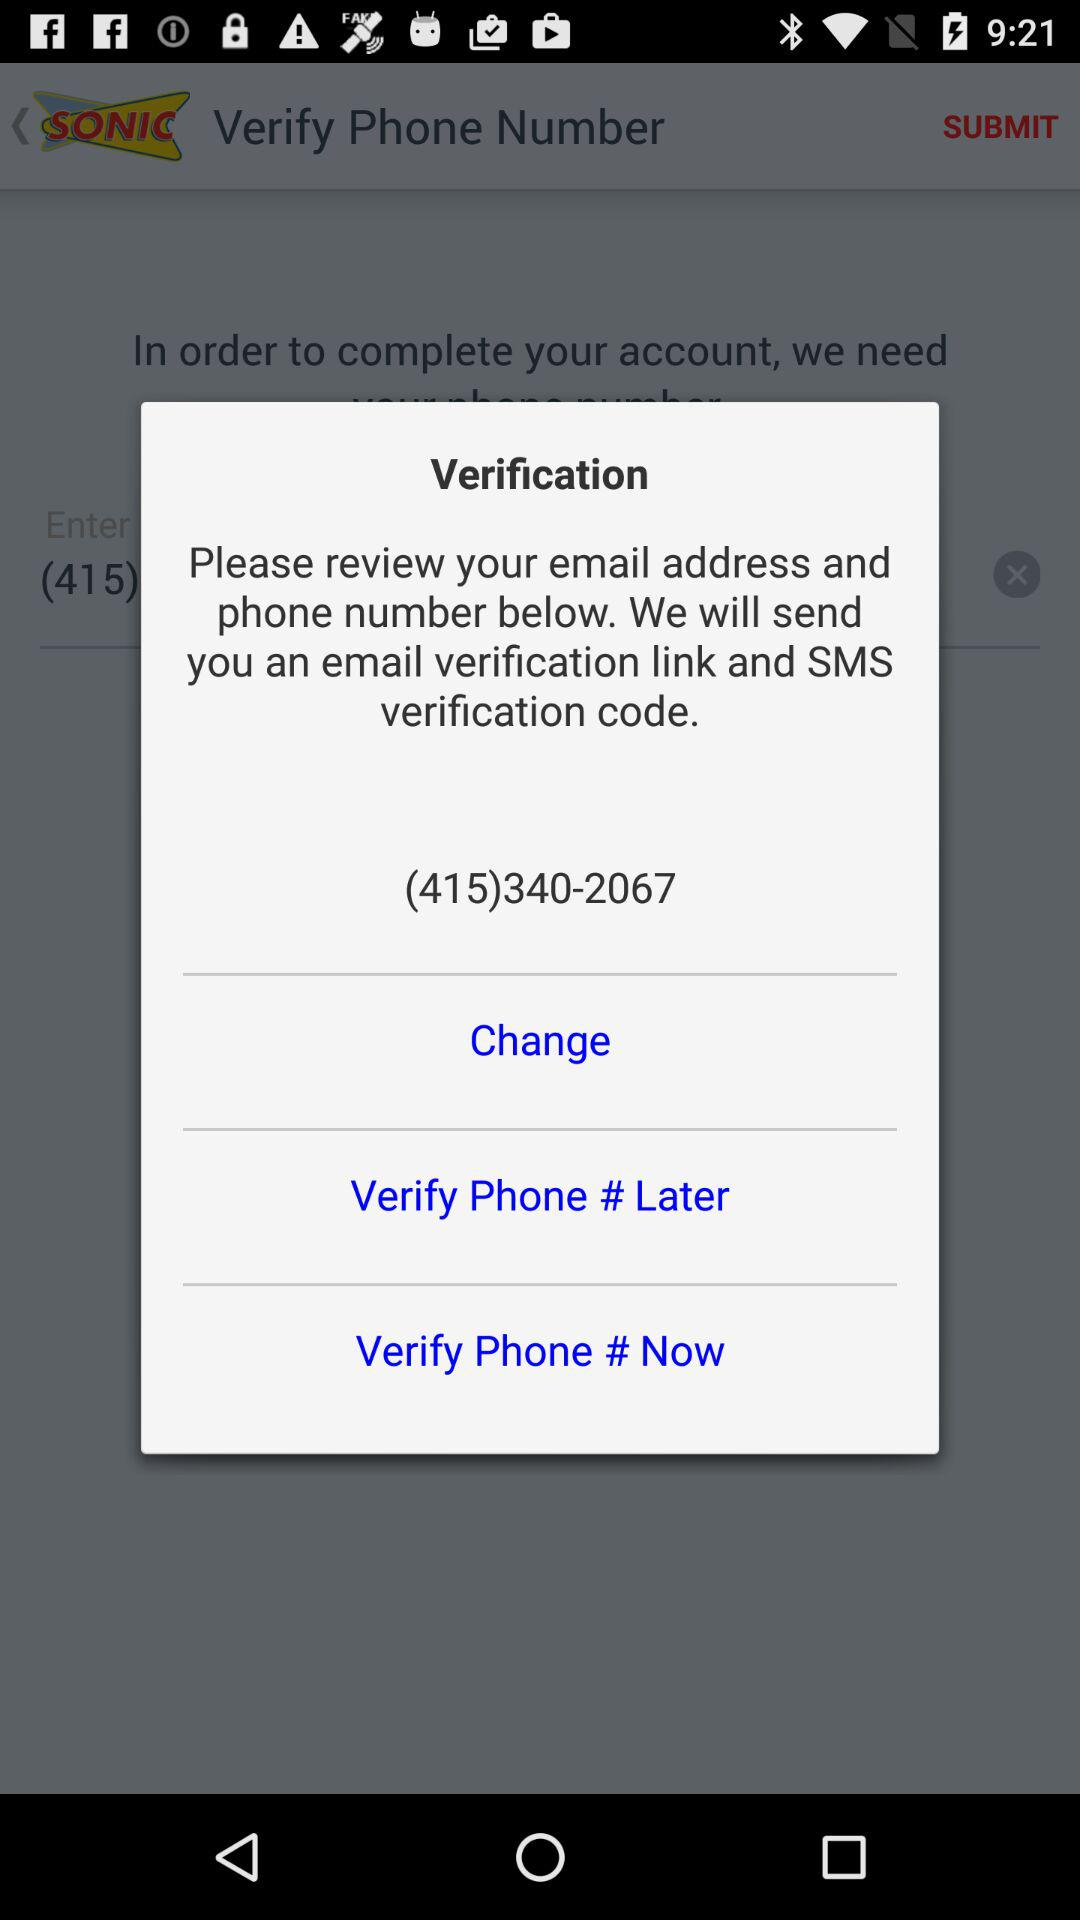How many digits are in the phone number?
Answer the question using a single word or phrase. 10 